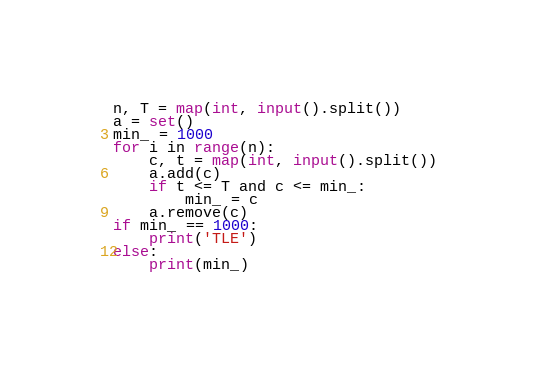<code> <loc_0><loc_0><loc_500><loc_500><_Python_>n, T = map(int, input().split())
a = set()
min_ = 1000
for i in range(n):
    c, t = map(int, input().split())
    a.add(c)
    if t <= T and c <= min_:
        min_ = c
    a.remove(c)
if min_ == 1000:
    print('TLE')
else:
    print(min_)</code> 